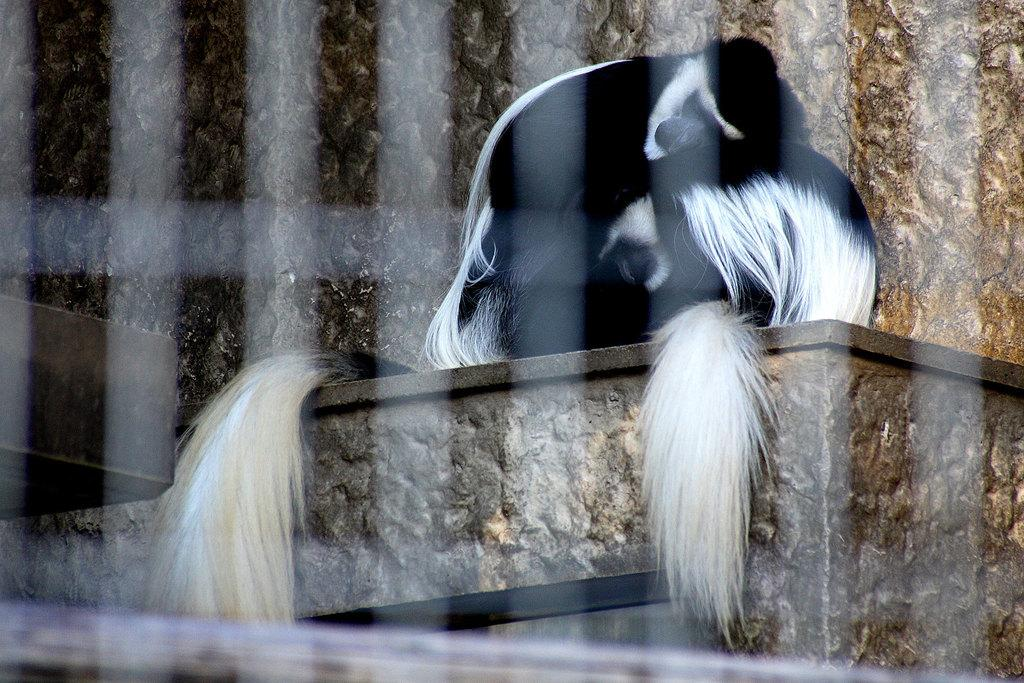What is visible in the background of the image? There is a wall in the background of the image. What type of living organisms can be seen in the image? There are animals present in the image. What type of agreement was reached between the animals in the image? There is no indication in the image of any agreement being reached between the animals. 